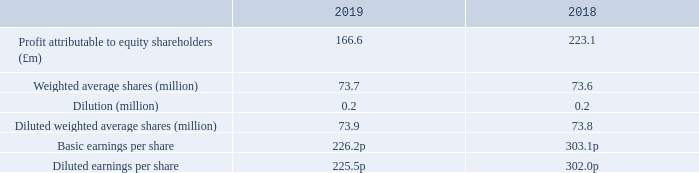10 Earnings per share
Basic and diluted earnings per share calculated on an adjusted profit basis are included in Note 2.
The dilution is in respect of unexercised share options and the Performance Share Plan.
On what basis is the basic and diluted earnings per share calculated on? An adjusted profit basis. What is the dilution of earnings per share in respect of? Unexercised share options and the performance share plan. What are the types of earnings per share? Basic, diluted. In which year was the weighted average shares larger? 73.7>73.6
Answer: 2019. What was the change in the profit attributable to equity shareholders from 2018 to 2019?
Answer scale should be: million. 166.6-223.1
Answer: -56.5. What was the percentage change in the profit attributable to equity shareholders from 2018 to 2019?
Answer scale should be: percent. (166.6-223.1)/223.1
Answer: -25.32. 